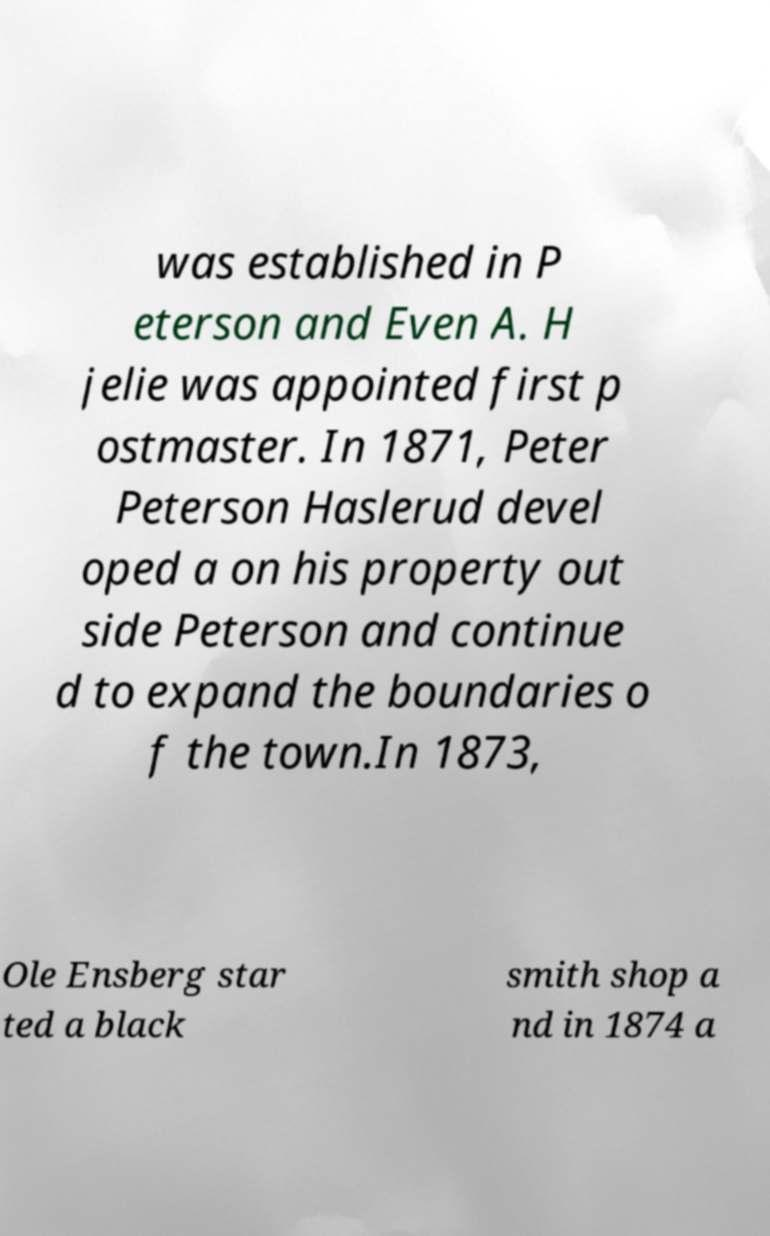Please identify and transcribe the text found in this image. was established in P eterson and Even A. H jelie was appointed first p ostmaster. In 1871, Peter Peterson Haslerud devel oped a on his property out side Peterson and continue d to expand the boundaries o f the town.In 1873, Ole Ensberg star ted a black smith shop a nd in 1874 a 